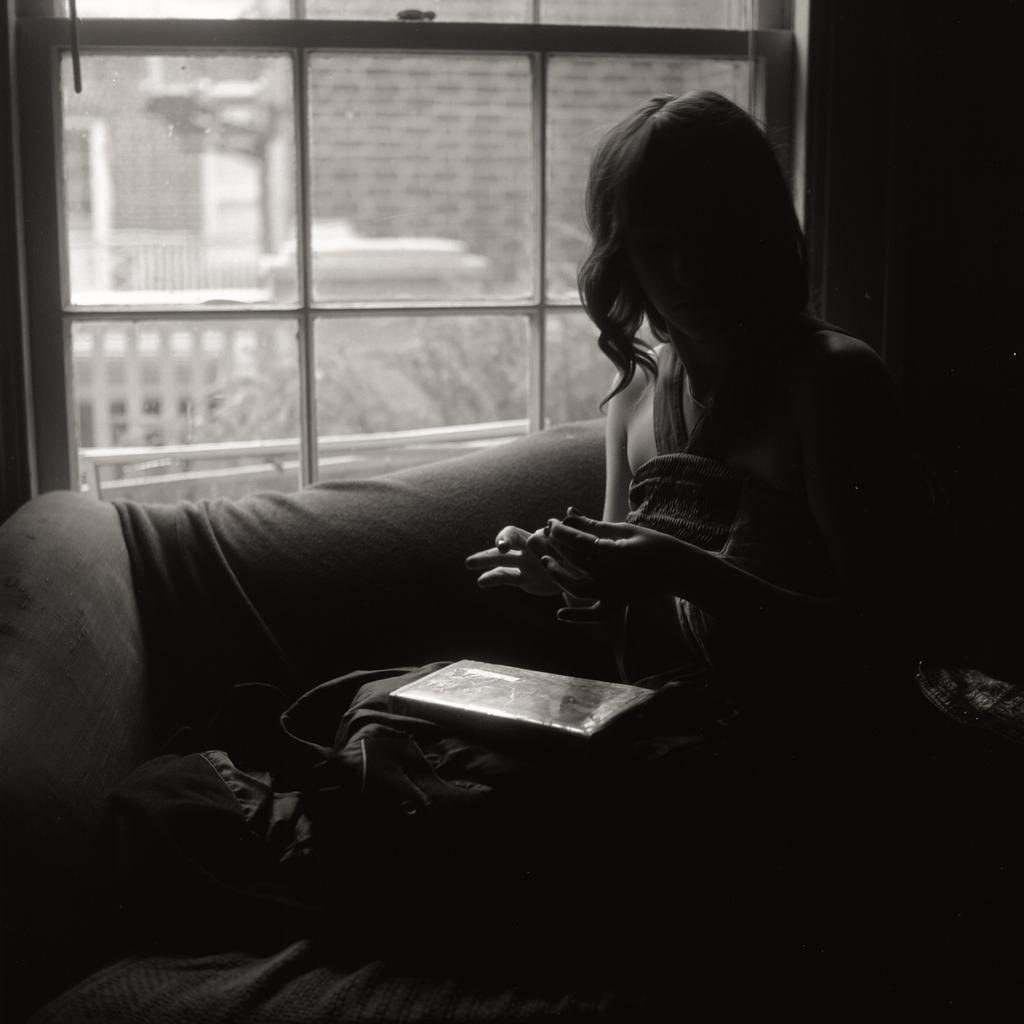In one or two sentences, can you explain what this image depicts? In this image there is a woman sitting on a sofa, in the background there is a glass window. 